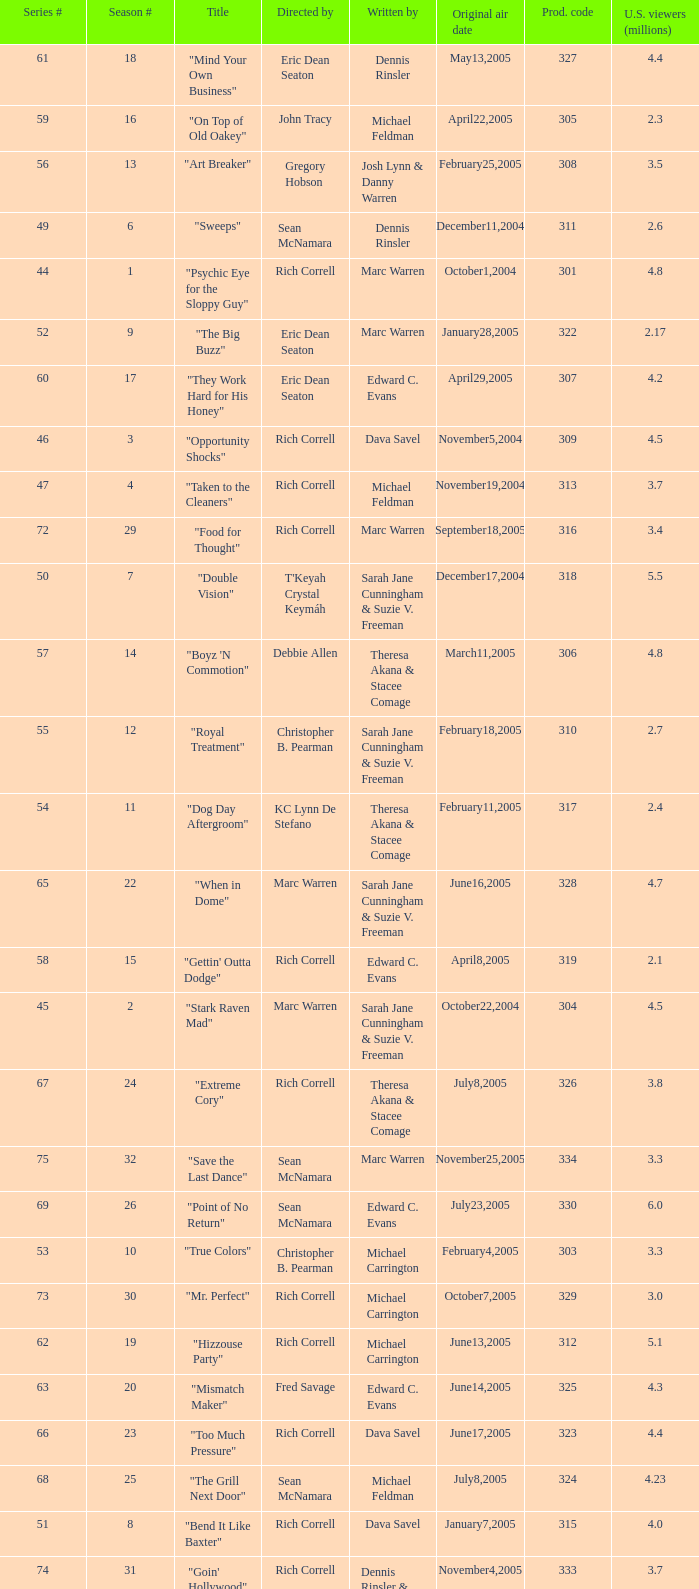What number episode in the season had a production code of 334? 32.0. 